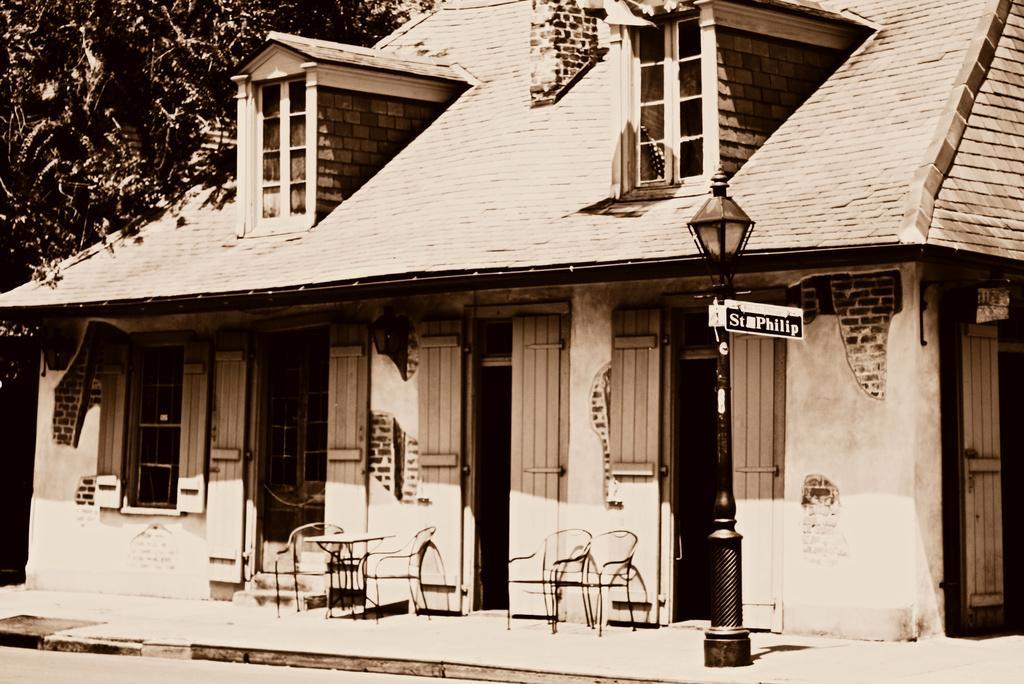In one or two sentences, can you explain what this image depicts? There is a house which has few chairs in front of it and there is a tree in the left corner. 